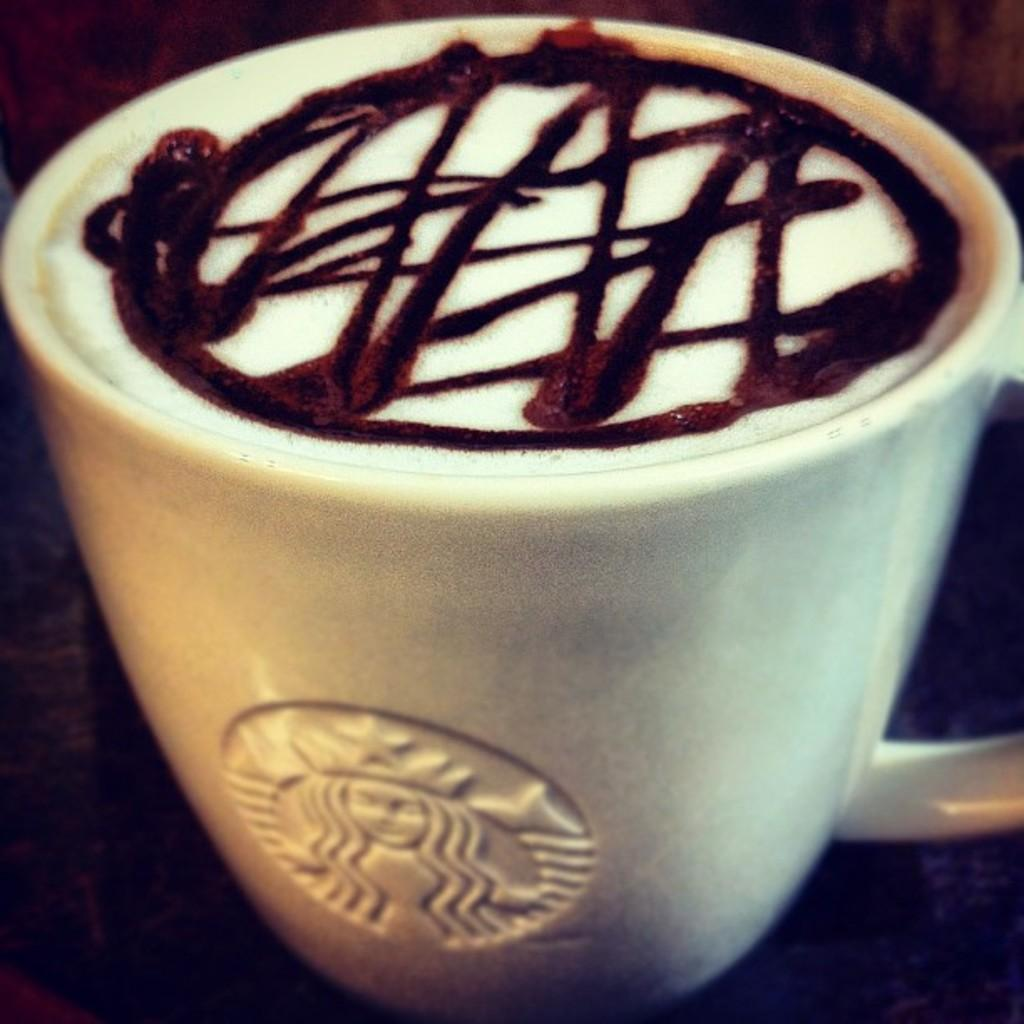What is in the cup that is visible in the image? There is a cup of coffee in the image. What design can be seen on the coffee's surface? The coffee has latte art. Is there any branding visible on the cup in the image? Yes, there is a Starbucks logo on a cup in the image. What type of meat is being cooked on the record player in the image? There is no meat or record player present in the image; it features a cup of coffee with latte art and a Starbucks logo. 